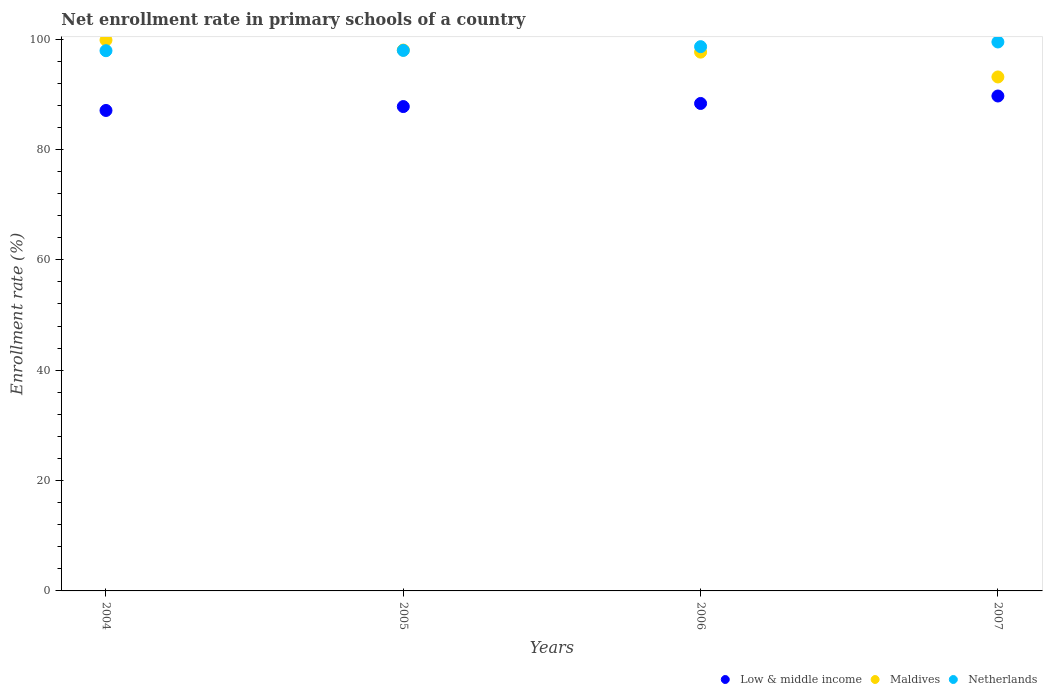What is the enrollment rate in primary schools in Low & middle income in 2005?
Your answer should be very brief. 87.78. Across all years, what is the maximum enrollment rate in primary schools in Low & middle income?
Make the answer very short. 89.69. Across all years, what is the minimum enrollment rate in primary schools in Maldives?
Give a very brief answer. 93.14. In which year was the enrollment rate in primary schools in Maldives maximum?
Keep it short and to the point. 2004. In which year was the enrollment rate in primary schools in Maldives minimum?
Provide a succinct answer. 2007. What is the total enrollment rate in primary schools in Low & middle income in the graph?
Your response must be concise. 352.87. What is the difference between the enrollment rate in primary schools in Netherlands in 2004 and that in 2007?
Offer a terse response. -1.58. What is the difference between the enrollment rate in primary schools in Netherlands in 2006 and the enrollment rate in primary schools in Maldives in 2005?
Give a very brief answer. 0.61. What is the average enrollment rate in primary schools in Maldives per year?
Keep it short and to the point. 97.16. In the year 2007, what is the difference between the enrollment rate in primary schools in Netherlands and enrollment rate in primary schools in Low & middle income?
Your answer should be very brief. 9.79. In how many years, is the enrollment rate in primary schools in Netherlands greater than 56 %?
Your answer should be very brief. 4. What is the ratio of the enrollment rate in primary schools in Netherlands in 2004 to that in 2006?
Make the answer very short. 0.99. What is the difference between the highest and the second highest enrollment rate in primary schools in Netherlands?
Give a very brief answer. 0.85. What is the difference between the highest and the lowest enrollment rate in primary schools in Maldives?
Provide a short and direct response. 6.68. Is it the case that in every year, the sum of the enrollment rate in primary schools in Maldives and enrollment rate in primary schools in Netherlands  is greater than the enrollment rate in primary schools in Low & middle income?
Offer a very short reply. Yes. Does the enrollment rate in primary schools in Maldives monotonically increase over the years?
Give a very brief answer. No. How many dotlines are there?
Ensure brevity in your answer.  3. Are the values on the major ticks of Y-axis written in scientific E-notation?
Your response must be concise. No. Where does the legend appear in the graph?
Keep it short and to the point. Bottom right. How are the legend labels stacked?
Your answer should be compact. Horizontal. What is the title of the graph?
Your answer should be very brief. Net enrollment rate in primary schools of a country. What is the label or title of the X-axis?
Offer a very short reply. Years. What is the label or title of the Y-axis?
Your answer should be compact. Enrollment rate (%). What is the Enrollment rate (%) in Low & middle income in 2004?
Make the answer very short. 87.07. What is the Enrollment rate (%) of Maldives in 2004?
Provide a succinct answer. 99.82. What is the Enrollment rate (%) of Netherlands in 2004?
Offer a terse response. 97.9. What is the Enrollment rate (%) in Low & middle income in 2005?
Give a very brief answer. 87.78. What is the Enrollment rate (%) of Maldives in 2005?
Provide a succinct answer. 98.02. What is the Enrollment rate (%) in Netherlands in 2005?
Provide a succinct answer. 97.95. What is the Enrollment rate (%) of Low & middle income in 2006?
Keep it short and to the point. 88.34. What is the Enrollment rate (%) in Maldives in 2006?
Ensure brevity in your answer.  97.64. What is the Enrollment rate (%) in Netherlands in 2006?
Keep it short and to the point. 98.63. What is the Enrollment rate (%) of Low & middle income in 2007?
Your answer should be compact. 89.69. What is the Enrollment rate (%) of Maldives in 2007?
Make the answer very short. 93.14. What is the Enrollment rate (%) in Netherlands in 2007?
Make the answer very short. 99.48. Across all years, what is the maximum Enrollment rate (%) of Low & middle income?
Make the answer very short. 89.69. Across all years, what is the maximum Enrollment rate (%) of Maldives?
Offer a very short reply. 99.82. Across all years, what is the maximum Enrollment rate (%) in Netherlands?
Offer a very short reply. 99.48. Across all years, what is the minimum Enrollment rate (%) in Low & middle income?
Provide a short and direct response. 87.07. Across all years, what is the minimum Enrollment rate (%) in Maldives?
Provide a short and direct response. 93.14. Across all years, what is the minimum Enrollment rate (%) of Netherlands?
Your response must be concise. 97.9. What is the total Enrollment rate (%) in Low & middle income in the graph?
Your answer should be very brief. 352.87. What is the total Enrollment rate (%) of Maldives in the graph?
Ensure brevity in your answer.  388.62. What is the total Enrollment rate (%) in Netherlands in the graph?
Make the answer very short. 393.96. What is the difference between the Enrollment rate (%) in Low & middle income in 2004 and that in 2005?
Give a very brief answer. -0.71. What is the difference between the Enrollment rate (%) in Maldives in 2004 and that in 2005?
Offer a terse response. 1.8. What is the difference between the Enrollment rate (%) in Netherlands in 2004 and that in 2005?
Make the answer very short. -0.05. What is the difference between the Enrollment rate (%) of Low & middle income in 2004 and that in 2006?
Give a very brief answer. -1.27. What is the difference between the Enrollment rate (%) in Maldives in 2004 and that in 2006?
Your response must be concise. 2.18. What is the difference between the Enrollment rate (%) of Netherlands in 2004 and that in 2006?
Your response must be concise. -0.73. What is the difference between the Enrollment rate (%) in Low & middle income in 2004 and that in 2007?
Ensure brevity in your answer.  -2.62. What is the difference between the Enrollment rate (%) in Maldives in 2004 and that in 2007?
Make the answer very short. 6.68. What is the difference between the Enrollment rate (%) of Netherlands in 2004 and that in 2007?
Ensure brevity in your answer.  -1.58. What is the difference between the Enrollment rate (%) in Low & middle income in 2005 and that in 2006?
Provide a short and direct response. -0.56. What is the difference between the Enrollment rate (%) of Maldives in 2005 and that in 2006?
Ensure brevity in your answer.  0.38. What is the difference between the Enrollment rate (%) in Netherlands in 2005 and that in 2006?
Provide a succinct answer. -0.68. What is the difference between the Enrollment rate (%) of Low & middle income in 2005 and that in 2007?
Your answer should be compact. -1.91. What is the difference between the Enrollment rate (%) in Maldives in 2005 and that in 2007?
Ensure brevity in your answer.  4.88. What is the difference between the Enrollment rate (%) in Netherlands in 2005 and that in 2007?
Offer a terse response. -1.53. What is the difference between the Enrollment rate (%) in Low & middle income in 2006 and that in 2007?
Your answer should be compact. -1.35. What is the difference between the Enrollment rate (%) in Maldives in 2006 and that in 2007?
Provide a succinct answer. 4.5. What is the difference between the Enrollment rate (%) in Netherlands in 2006 and that in 2007?
Ensure brevity in your answer.  -0.85. What is the difference between the Enrollment rate (%) in Low & middle income in 2004 and the Enrollment rate (%) in Maldives in 2005?
Keep it short and to the point. -10.95. What is the difference between the Enrollment rate (%) in Low & middle income in 2004 and the Enrollment rate (%) in Netherlands in 2005?
Provide a succinct answer. -10.88. What is the difference between the Enrollment rate (%) in Maldives in 2004 and the Enrollment rate (%) in Netherlands in 2005?
Make the answer very short. 1.87. What is the difference between the Enrollment rate (%) in Low & middle income in 2004 and the Enrollment rate (%) in Maldives in 2006?
Your response must be concise. -10.57. What is the difference between the Enrollment rate (%) of Low & middle income in 2004 and the Enrollment rate (%) of Netherlands in 2006?
Offer a terse response. -11.56. What is the difference between the Enrollment rate (%) of Maldives in 2004 and the Enrollment rate (%) of Netherlands in 2006?
Provide a succinct answer. 1.19. What is the difference between the Enrollment rate (%) of Low & middle income in 2004 and the Enrollment rate (%) of Maldives in 2007?
Make the answer very short. -6.07. What is the difference between the Enrollment rate (%) of Low & middle income in 2004 and the Enrollment rate (%) of Netherlands in 2007?
Ensure brevity in your answer.  -12.41. What is the difference between the Enrollment rate (%) of Maldives in 2004 and the Enrollment rate (%) of Netherlands in 2007?
Your answer should be very brief. 0.34. What is the difference between the Enrollment rate (%) in Low & middle income in 2005 and the Enrollment rate (%) in Maldives in 2006?
Ensure brevity in your answer.  -9.86. What is the difference between the Enrollment rate (%) of Low & middle income in 2005 and the Enrollment rate (%) of Netherlands in 2006?
Offer a very short reply. -10.85. What is the difference between the Enrollment rate (%) of Maldives in 2005 and the Enrollment rate (%) of Netherlands in 2006?
Keep it short and to the point. -0.61. What is the difference between the Enrollment rate (%) of Low & middle income in 2005 and the Enrollment rate (%) of Maldives in 2007?
Give a very brief answer. -5.37. What is the difference between the Enrollment rate (%) in Low & middle income in 2005 and the Enrollment rate (%) in Netherlands in 2007?
Offer a terse response. -11.7. What is the difference between the Enrollment rate (%) of Maldives in 2005 and the Enrollment rate (%) of Netherlands in 2007?
Your answer should be compact. -1.46. What is the difference between the Enrollment rate (%) of Low & middle income in 2006 and the Enrollment rate (%) of Maldives in 2007?
Provide a short and direct response. -4.8. What is the difference between the Enrollment rate (%) of Low & middle income in 2006 and the Enrollment rate (%) of Netherlands in 2007?
Offer a terse response. -11.14. What is the difference between the Enrollment rate (%) in Maldives in 2006 and the Enrollment rate (%) in Netherlands in 2007?
Your response must be concise. -1.84. What is the average Enrollment rate (%) in Low & middle income per year?
Ensure brevity in your answer.  88.22. What is the average Enrollment rate (%) of Maldives per year?
Keep it short and to the point. 97.16. What is the average Enrollment rate (%) of Netherlands per year?
Give a very brief answer. 98.49. In the year 2004, what is the difference between the Enrollment rate (%) of Low & middle income and Enrollment rate (%) of Maldives?
Keep it short and to the point. -12.75. In the year 2004, what is the difference between the Enrollment rate (%) of Low & middle income and Enrollment rate (%) of Netherlands?
Your answer should be compact. -10.83. In the year 2004, what is the difference between the Enrollment rate (%) of Maldives and Enrollment rate (%) of Netherlands?
Provide a succinct answer. 1.92. In the year 2005, what is the difference between the Enrollment rate (%) of Low & middle income and Enrollment rate (%) of Maldives?
Ensure brevity in your answer.  -10.24. In the year 2005, what is the difference between the Enrollment rate (%) in Low & middle income and Enrollment rate (%) in Netherlands?
Make the answer very short. -10.17. In the year 2005, what is the difference between the Enrollment rate (%) in Maldives and Enrollment rate (%) in Netherlands?
Provide a succinct answer. 0.07. In the year 2006, what is the difference between the Enrollment rate (%) of Low & middle income and Enrollment rate (%) of Maldives?
Ensure brevity in your answer.  -9.3. In the year 2006, what is the difference between the Enrollment rate (%) of Low & middle income and Enrollment rate (%) of Netherlands?
Give a very brief answer. -10.29. In the year 2006, what is the difference between the Enrollment rate (%) in Maldives and Enrollment rate (%) in Netherlands?
Your answer should be compact. -0.99. In the year 2007, what is the difference between the Enrollment rate (%) in Low & middle income and Enrollment rate (%) in Maldives?
Offer a very short reply. -3.45. In the year 2007, what is the difference between the Enrollment rate (%) in Low & middle income and Enrollment rate (%) in Netherlands?
Your answer should be compact. -9.79. In the year 2007, what is the difference between the Enrollment rate (%) of Maldives and Enrollment rate (%) of Netherlands?
Your response must be concise. -6.34. What is the ratio of the Enrollment rate (%) of Maldives in 2004 to that in 2005?
Your response must be concise. 1.02. What is the ratio of the Enrollment rate (%) of Netherlands in 2004 to that in 2005?
Provide a short and direct response. 1. What is the ratio of the Enrollment rate (%) in Low & middle income in 2004 to that in 2006?
Keep it short and to the point. 0.99. What is the ratio of the Enrollment rate (%) of Maldives in 2004 to that in 2006?
Offer a terse response. 1.02. What is the ratio of the Enrollment rate (%) of Netherlands in 2004 to that in 2006?
Your answer should be very brief. 0.99. What is the ratio of the Enrollment rate (%) of Low & middle income in 2004 to that in 2007?
Give a very brief answer. 0.97. What is the ratio of the Enrollment rate (%) in Maldives in 2004 to that in 2007?
Your response must be concise. 1.07. What is the ratio of the Enrollment rate (%) in Netherlands in 2004 to that in 2007?
Offer a very short reply. 0.98. What is the ratio of the Enrollment rate (%) in Low & middle income in 2005 to that in 2006?
Your answer should be compact. 0.99. What is the ratio of the Enrollment rate (%) of Maldives in 2005 to that in 2006?
Provide a short and direct response. 1. What is the ratio of the Enrollment rate (%) of Low & middle income in 2005 to that in 2007?
Your answer should be very brief. 0.98. What is the ratio of the Enrollment rate (%) in Maldives in 2005 to that in 2007?
Your answer should be very brief. 1.05. What is the ratio of the Enrollment rate (%) of Netherlands in 2005 to that in 2007?
Make the answer very short. 0.98. What is the ratio of the Enrollment rate (%) of Low & middle income in 2006 to that in 2007?
Your answer should be compact. 0.98. What is the ratio of the Enrollment rate (%) of Maldives in 2006 to that in 2007?
Your answer should be very brief. 1.05. What is the ratio of the Enrollment rate (%) in Netherlands in 2006 to that in 2007?
Ensure brevity in your answer.  0.99. What is the difference between the highest and the second highest Enrollment rate (%) of Low & middle income?
Your response must be concise. 1.35. What is the difference between the highest and the second highest Enrollment rate (%) of Maldives?
Offer a terse response. 1.8. What is the difference between the highest and the second highest Enrollment rate (%) in Netherlands?
Offer a terse response. 0.85. What is the difference between the highest and the lowest Enrollment rate (%) in Low & middle income?
Offer a terse response. 2.62. What is the difference between the highest and the lowest Enrollment rate (%) in Maldives?
Ensure brevity in your answer.  6.68. What is the difference between the highest and the lowest Enrollment rate (%) of Netherlands?
Offer a terse response. 1.58. 